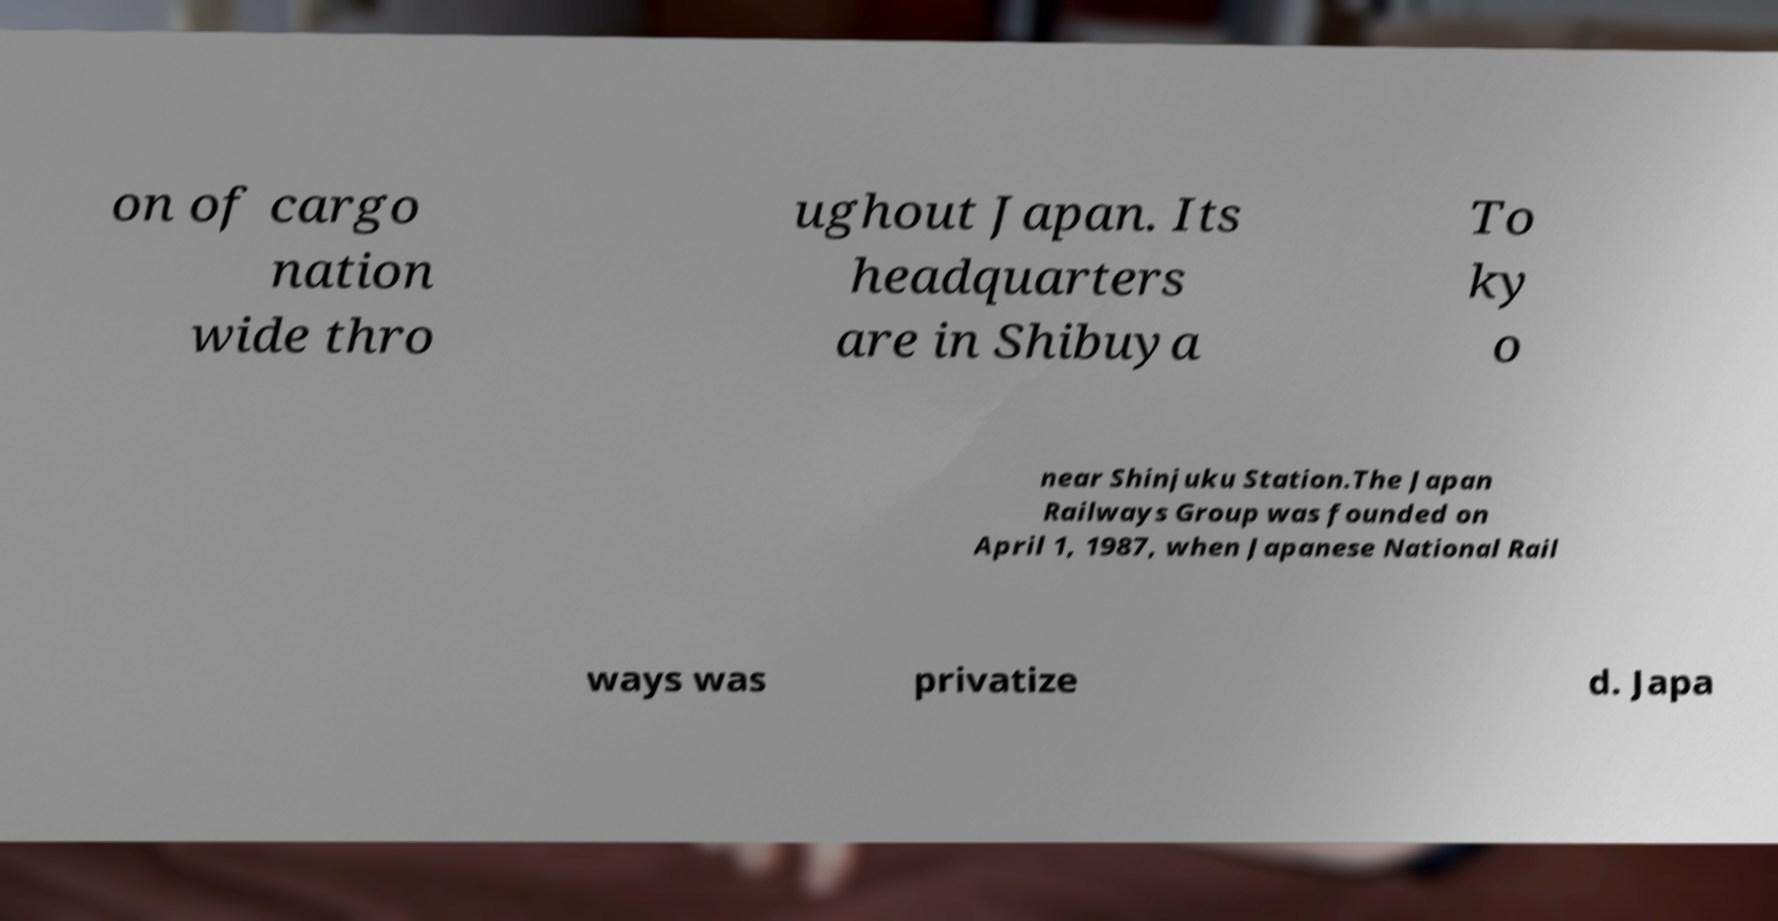There's text embedded in this image that I need extracted. Can you transcribe it verbatim? on of cargo nation wide thro ughout Japan. Its headquarters are in Shibuya To ky o near Shinjuku Station.The Japan Railways Group was founded on April 1, 1987, when Japanese National Rail ways was privatize d. Japa 